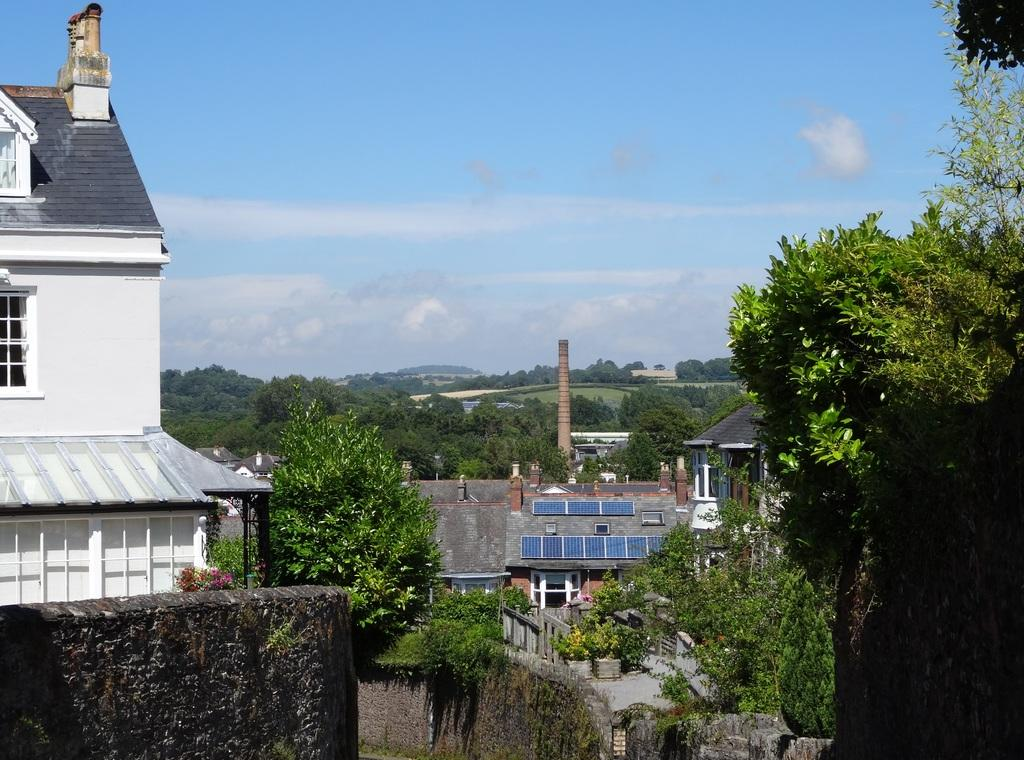What is present on the wall in the image? The facts provided do not specify any details about the wall. What type of plants can be seen in the image? There are plants in the image. What type of structure is visible in the image? There is a house in the image. What can be seen in the background of the image? There are buildings and trees in the background of the image. What is visible in the sky in the image? The sky is visible in the background of the image, and there are clouds in the sky. What type of fuel is being used by the carriage in the image? There is no carriage present in the image. How many units are visible in the image? The facts provided do not specify any details about units. 